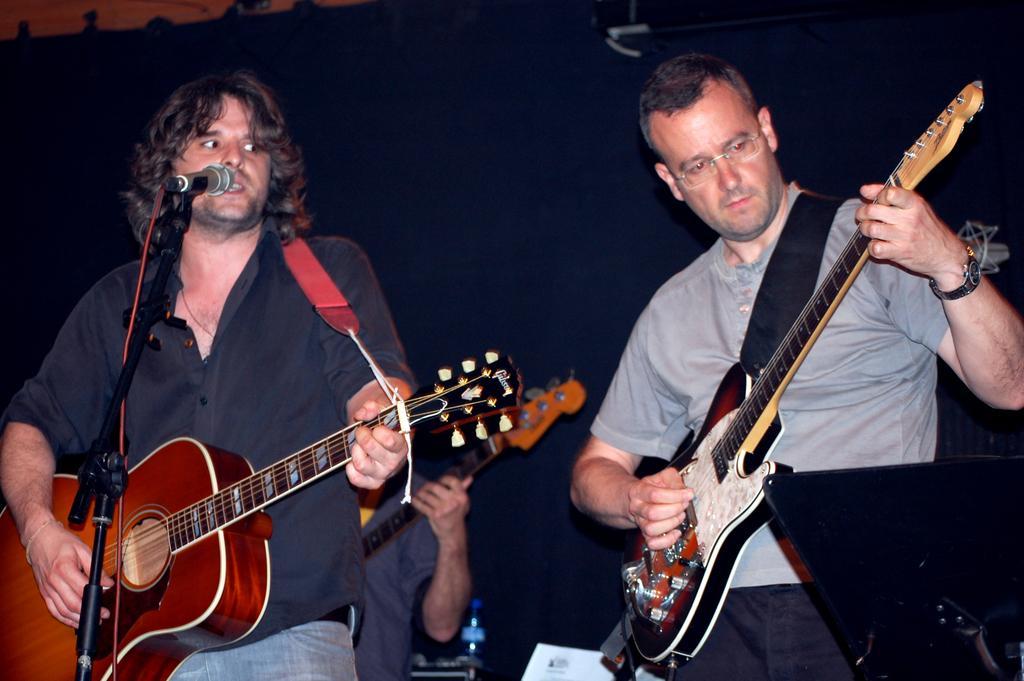Describe this image in one or two sentences. There are two persons standing. They are holding guitar and they are playing guitars. This is a mike with a mike stand. At background I can see another person standing. This is looks like a water bottle. 